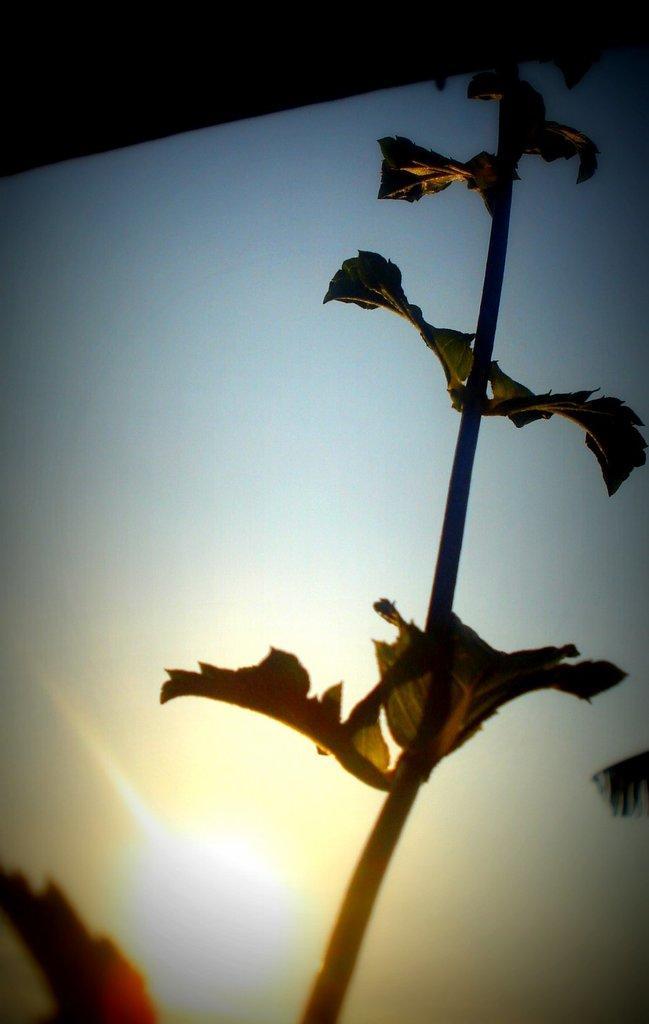In one or two sentences, can you explain what this image depicts? In this image I can see a plant, the sky and the sun. To the top of the image I can see the black colored object. 